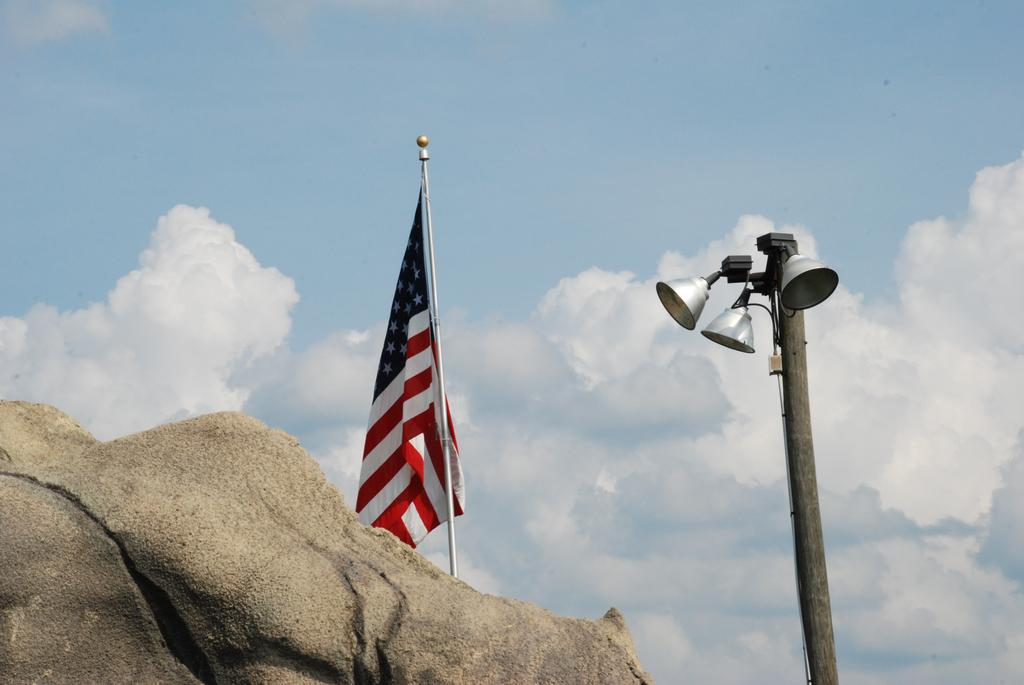What is the main object in the image? There is a flag in the image. What is attached to the flagpole? There are lights on the pole. What can be seen in the foreground of the image? There is a rock in the foreground of the image. What is visible at the top of the image? The sky is visible at the top of the image. What can be observed in the sky? There are clouds in the sky. What type of birthday celebration is taking place in the image? There is no indication of a birthday celebration in the image; it features a flag, lights, a rock, and clouds. Can you see any leaves falling from the trees in the image? There are no trees present in the image, so it is not possible to see any leaves falling. 